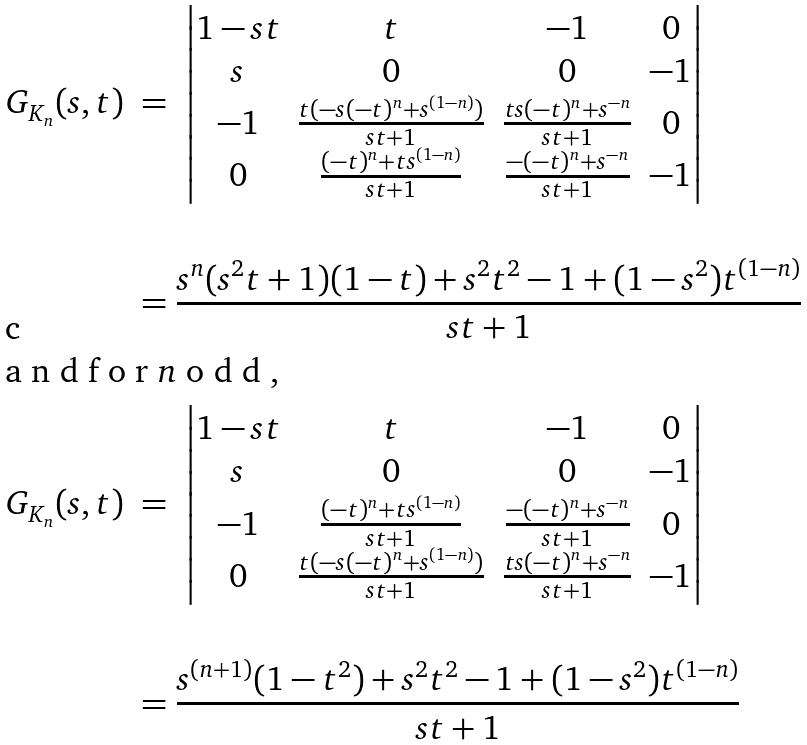<formula> <loc_0><loc_0><loc_500><loc_500>G _ { K _ { n } } ( s , t ) \ & = \ { \begin{vmatrix} 1 - s t & t & - 1 & 0 \\ s & 0 & 0 & - 1 \\ - 1 & \frac { t ( - s ( - t ) ^ { n } + s ^ { ( 1 - n ) } ) } { s t + 1 } & \frac { t s ( - t ) ^ { n } + s ^ { - n } } { s t + 1 } & 0 \\ 0 & \frac { ( - t ) ^ { n } + t s ^ { ( 1 - n ) } } { s t + 1 } & \frac { - ( - t ) ^ { n } + s ^ { - n } } { s t + 1 } & - 1 \end{vmatrix} } \\ \\ & = \frac { s ^ { n } ( s ^ { 2 } t + 1 ) ( 1 - t ) + s ^ { 2 } t ^ { 2 } - 1 + ( 1 - s ^ { 2 } ) t ^ { ( 1 - n ) } } { s t + 1 } \\ \intertext { a n d f o r $ n $ o d d , } G _ { K _ { n } } ( s , t ) \ & = \ { \begin{vmatrix} 1 - s t & t & - 1 & 0 \\ s & 0 & 0 & - 1 \\ - 1 & \frac { ( - t ) ^ { n } + t s ^ { ( 1 - n ) } } { s t + 1 } & \frac { - ( - t ) ^ { n } + s ^ { - n } } { s t + 1 } & 0 \\ 0 & \frac { t ( - s ( - t ) ^ { n } + s ^ { ( 1 - n ) } ) } { s t + 1 } & \frac { t s ( - t ) ^ { n } + s ^ { - n } } { s t + 1 } & - 1 \end{vmatrix} } \\ \\ & = \frac { s ^ { ( n + 1 ) } ( 1 - t ^ { 2 } ) + s ^ { 2 } t ^ { 2 } - 1 + ( 1 - s ^ { 2 } ) t ^ { ( 1 - n ) } } { s t + 1 }</formula> 